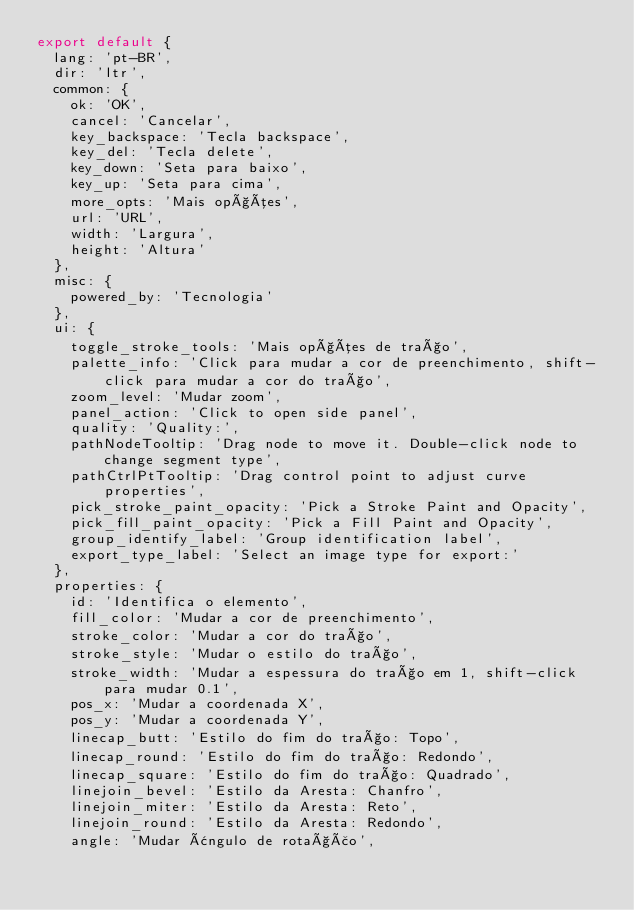<code> <loc_0><loc_0><loc_500><loc_500><_JavaScript_>export default {
  lang: 'pt-BR',
  dir: 'ltr',
  common: {
    ok: 'OK',
    cancel: 'Cancelar',
    key_backspace: 'Tecla backspace',
    key_del: 'Tecla delete',
    key_down: 'Seta para baixo',
    key_up: 'Seta para cima',
    more_opts: 'Mais opções',
    url: 'URL',
    width: 'Largura',
    height: 'Altura'
  },
  misc: {
    powered_by: 'Tecnologia'
  },
  ui: {
    toggle_stroke_tools: 'Mais opções de traço',
    palette_info: 'Click para mudar a cor de preenchimento, shift-click para mudar a cor do traço',
    zoom_level: 'Mudar zoom',
    panel_action: 'Click to open side panel',
    quality: 'Quality:',
    pathNodeTooltip: 'Drag node to move it. Double-click node to change segment type',
    pathCtrlPtTooltip: 'Drag control point to adjust curve properties',
    pick_stroke_paint_opacity: 'Pick a Stroke Paint and Opacity',
    pick_fill_paint_opacity: 'Pick a Fill Paint and Opacity',
    group_identify_label: 'Group identification label',
    export_type_label: 'Select an image type for export:'
  },
  properties: {
    id: 'Identifica o elemento',
    fill_color: 'Mudar a cor de preenchimento',
    stroke_color: 'Mudar a cor do traço',
    stroke_style: 'Mudar o estilo do traço',
    stroke_width: 'Mudar a espessura do traço em 1, shift-click para mudar 0.1',
    pos_x: 'Mudar a coordenada X',
    pos_y: 'Mudar a coordenada Y',
    linecap_butt: 'Estilo do fim do traço: Topo',
    linecap_round: 'Estilo do fim do traço: Redondo',
    linecap_square: 'Estilo do fim do traço: Quadrado',
    linejoin_bevel: 'Estilo da Aresta: Chanfro',
    linejoin_miter: 'Estilo da Aresta: Reto',
    linejoin_round: 'Estilo da Aresta: Redondo',
    angle: 'Mudar ângulo de rotação',</code> 